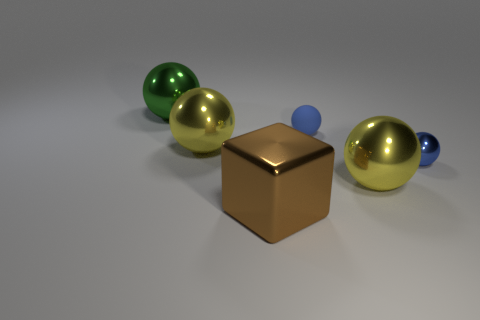Subtract all green balls. How many balls are left? 4 Subtract all tiny blue metallic balls. How many balls are left? 4 Subtract all purple spheres. Subtract all green cubes. How many spheres are left? 5 Add 1 tiny red metal cylinders. How many objects exist? 7 Subtract all blocks. How many objects are left? 5 Subtract 0 yellow blocks. How many objects are left? 6 Subtract all big brown cubes. Subtract all yellow shiny objects. How many objects are left? 3 Add 5 small things. How many small things are left? 7 Add 6 tiny green balls. How many tiny green balls exist? 6 